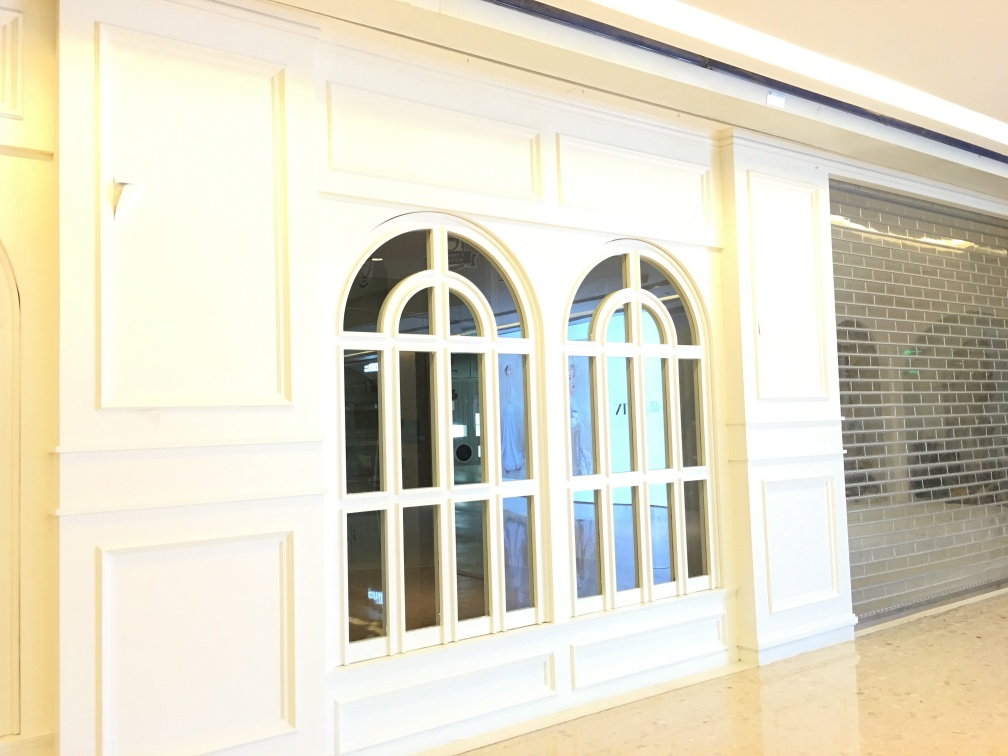How are the texture details of the architectural subject?
A. enhanced
B. preserved adequately
C. blurred
Answer with the option's letter from the given choices directly.
 B. 